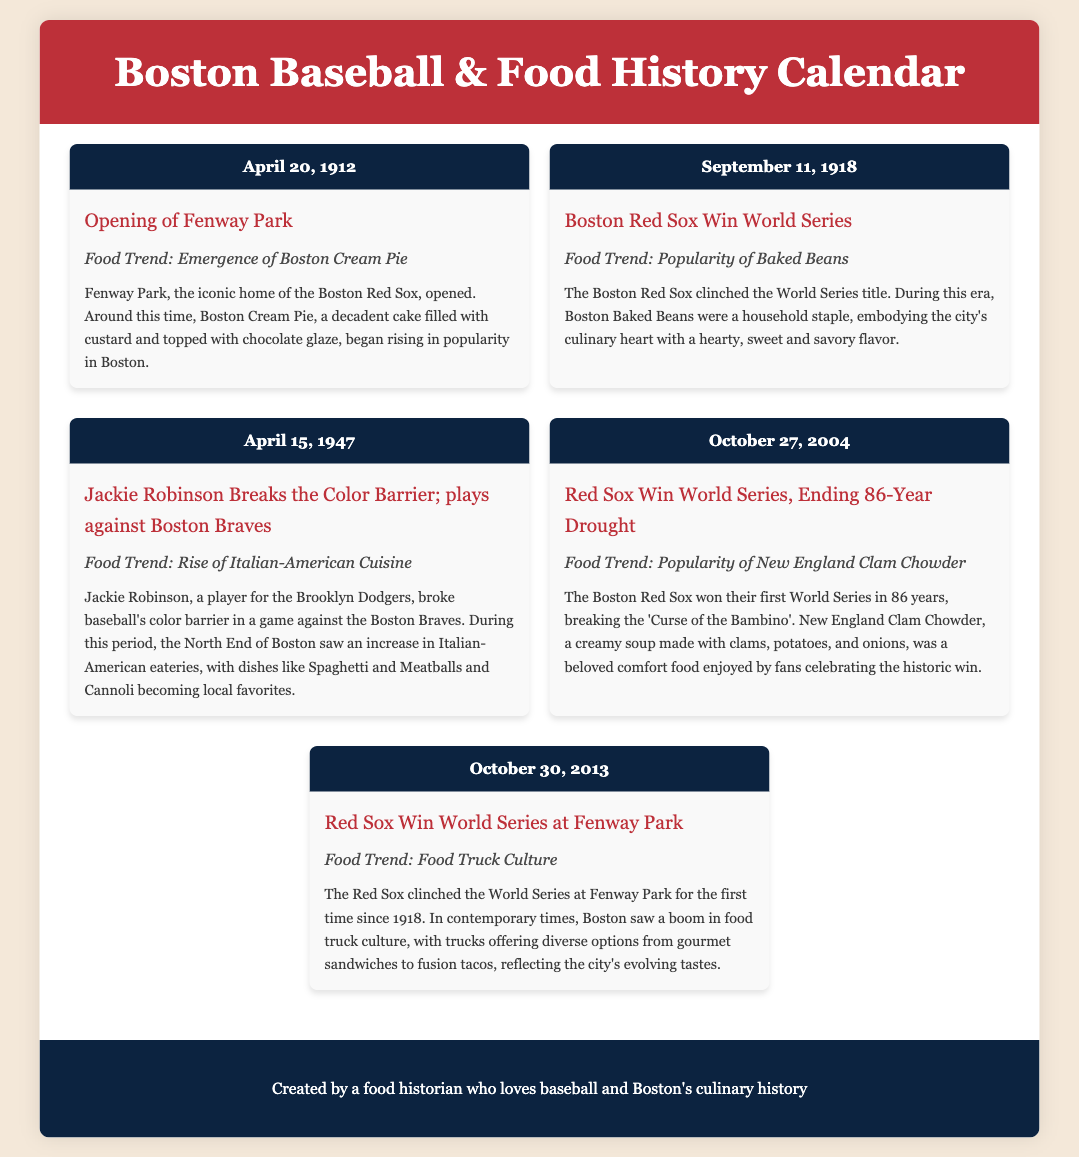What date did Fenway Park open? Fenway Park opened on April 20, 1912.
Answer: April 20, 1912 What food trend emerged when Fenway Park opened? The food trend that emerged was Boston Cream Pie.
Answer: Boston Cream Pie How many years did the Red Sox wait to win the World Series again after 1918? The Red Sox waited 86 years to win the World Series again after 1918.
Answer: 86 years What notable food trend rose alongside Jackie Robinson breaking the color barrier? The notable food trend was the rise of Italian-American Cuisine.
Answer: Rise of Italian-American Cuisine When did the Red Sox win the World Series at Fenway Park? The Red Sox won the World Series at Fenway Park on October 30, 2013.
Answer: October 30, 2013 What type of food became popular after the Red Sox's 2004 World Series win? The type of food that became popular was New England Clam Chowder.
Answer: New England Clam Chowder What was a significant culinary trend in Boston in 2013? A significant culinary trend in 2013 was Food Truck Culture.
Answer: Food Truck Culture Who played against the Boston Braves when Jackie Robinson broke the color barrier? Jackie Robinson played against the Boston Braves.
Answer: Boston Braves What was the description of Boston Baked Beans in the document? Boston Baked Beans were described as a hearty, sweet and savory flavor.
Answer: Hearty, sweet and savory flavor 